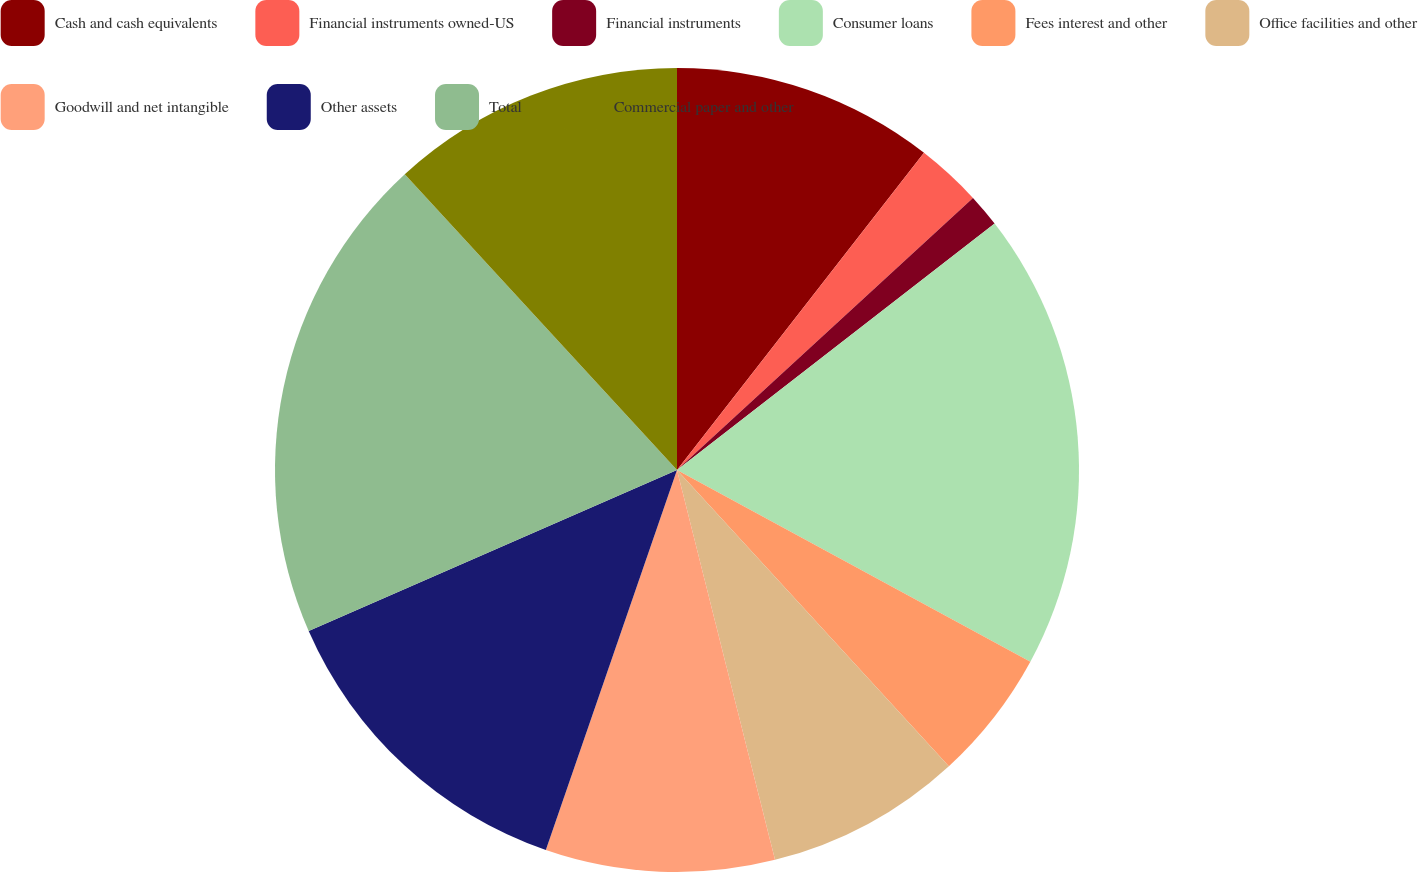<chart> <loc_0><loc_0><loc_500><loc_500><pie_chart><fcel>Cash and cash equivalents<fcel>Financial instruments owned-US<fcel>Financial instruments<fcel>Consumer loans<fcel>Fees interest and other<fcel>Office facilities and other<fcel>Goodwill and net intangible<fcel>Other assets<fcel>Total<fcel>Commercial paper and other<nl><fcel>10.53%<fcel>2.64%<fcel>1.33%<fcel>18.41%<fcel>5.27%<fcel>7.9%<fcel>9.21%<fcel>13.15%<fcel>19.72%<fcel>11.84%<nl></chart> 